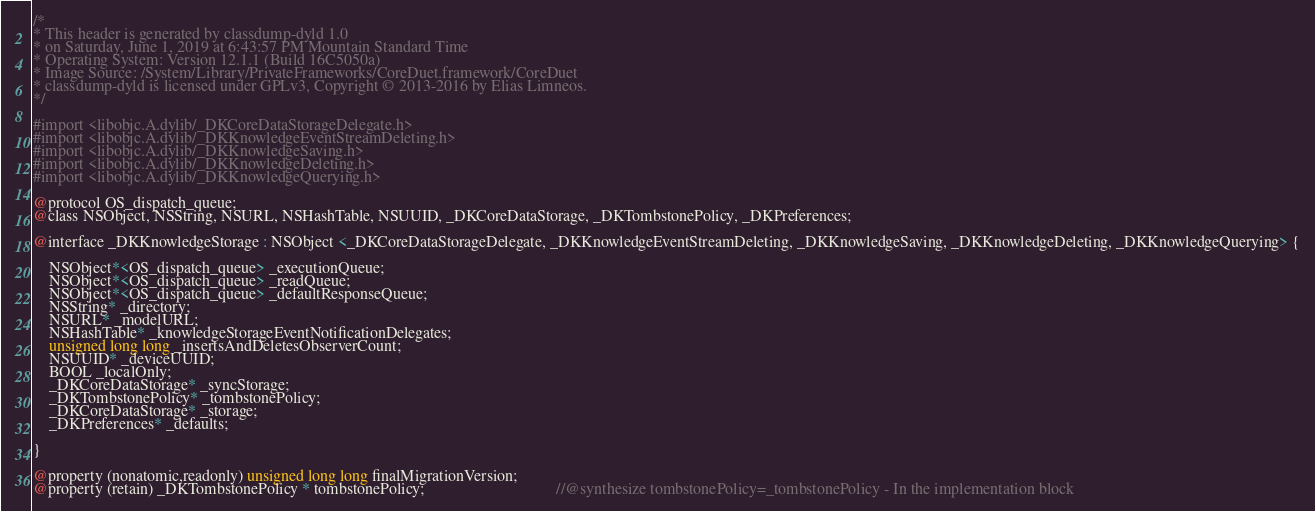Convert code to text. <code><loc_0><loc_0><loc_500><loc_500><_C_>/*
* This header is generated by classdump-dyld 1.0
* on Saturday, June 1, 2019 at 6:43:57 PM Mountain Standard Time
* Operating System: Version 12.1.1 (Build 16C5050a)
* Image Source: /System/Library/PrivateFrameworks/CoreDuet.framework/CoreDuet
* classdump-dyld is licensed under GPLv3, Copyright © 2013-2016 by Elias Limneos.
*/

#import <libobjc.A.dylib/_DKCoreDataStorageDelegate.h>
#import <libobjc.A.dylib/_DKKnowledgeEventStreamDeleting.h>
#import <libobjc.A.dylib/_DKKnowledgeSaving.h>
#import <libobjc.A.dylib/_DKKnowledgeDeleting.h>
#import <libobjc.A.dylib/_DKKnowledgeQuerying.h>

@protocol OS_dispatch_queue;
@class NSObject, NSString, NSURL, NSHashTable, NSUUID, _DKCoreDataStorage, _DKTombstonePolicy, _DKPreferences;

@interface _DKKnowledgeStorage : NSObject <_DKCoreDataStorageDelegate, _DKKnowledgeEventStreamDeleting, _DKKnowledgeSaving, _DKKnowledgeDeleting, _DKKnowledgeQuerying> {

	NSObject*<OS_dispatch_queue> _executionQueue;
	NSObject*<OS_dispatch_queue> _readQueue;
	NSObject*<OS_dispatch_queue> _defaultResponseQueue;
	NSString* _directory;
	NSURL* _modelURL;
	NSHashTable* _knowledgeStorageEventNotificationDelegates;
	unsigned long long _insertsAndDeletesObserverCount;
	NSUUID* _deviceUUID;
	BOOL _localOnly;
	_DKCoreDataStorage* _syncStorage;
	_DKTombstonePolicy* _tombstonePolicy;
	_DKCoreDataStorage* _storage;
	_DKPreferences* _defaults;

}

@property (nonatomic,readonly) unsigned long long finalMigrationVersion; 
@property (retain) _DKTombstonePolicy * tombstonePolicy;                                 //@synthesize tombstonePolicy=_tombstonePolicy - In the implementation block</code> 